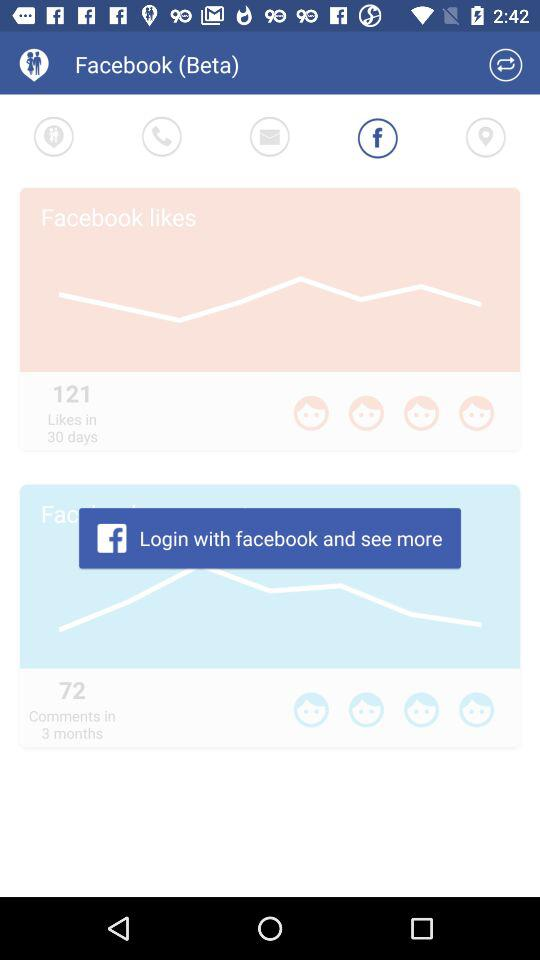Through what application do I have to login? The application is "facebook". 